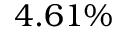<formula> <loc_0><loc_0><loc_500><loc_500>4 . 6 1 \%</formula> 